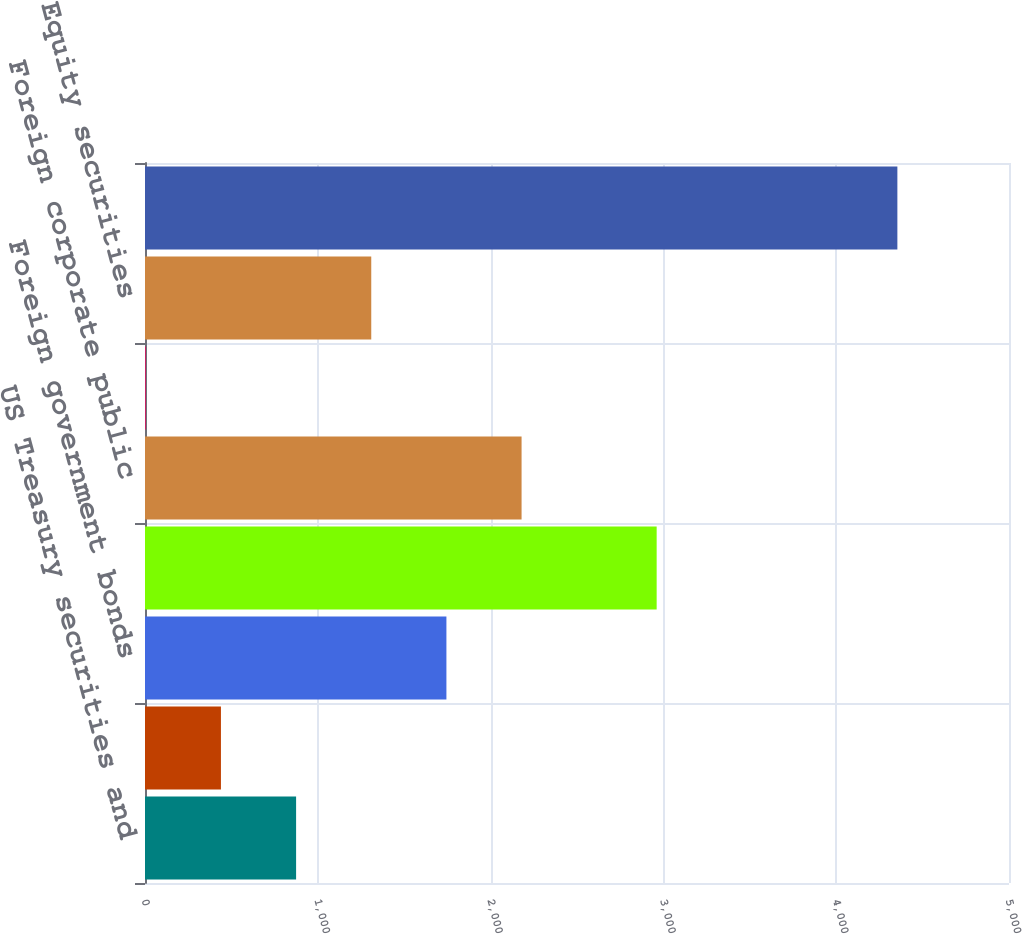<chart> <loc_0><loc_0><loc_500><loc_500><bar_chart><fcel>US Treasury securities and<fcel>Obligations of US states and<fcel>Foreign government bonds<fcel>US corporate public securities<fcel>Foreign corporate public<fcel>Residential mortgage-backed<fcel>Equity securities<fcel>Total cash collateral for<nl><fcel>874.41<fcel>439.46<fcel>1744.31<fcel>2961<fcel>2179.26<fcel>4.51<fcel>1309.36<fcel>4354<nl></chart> 